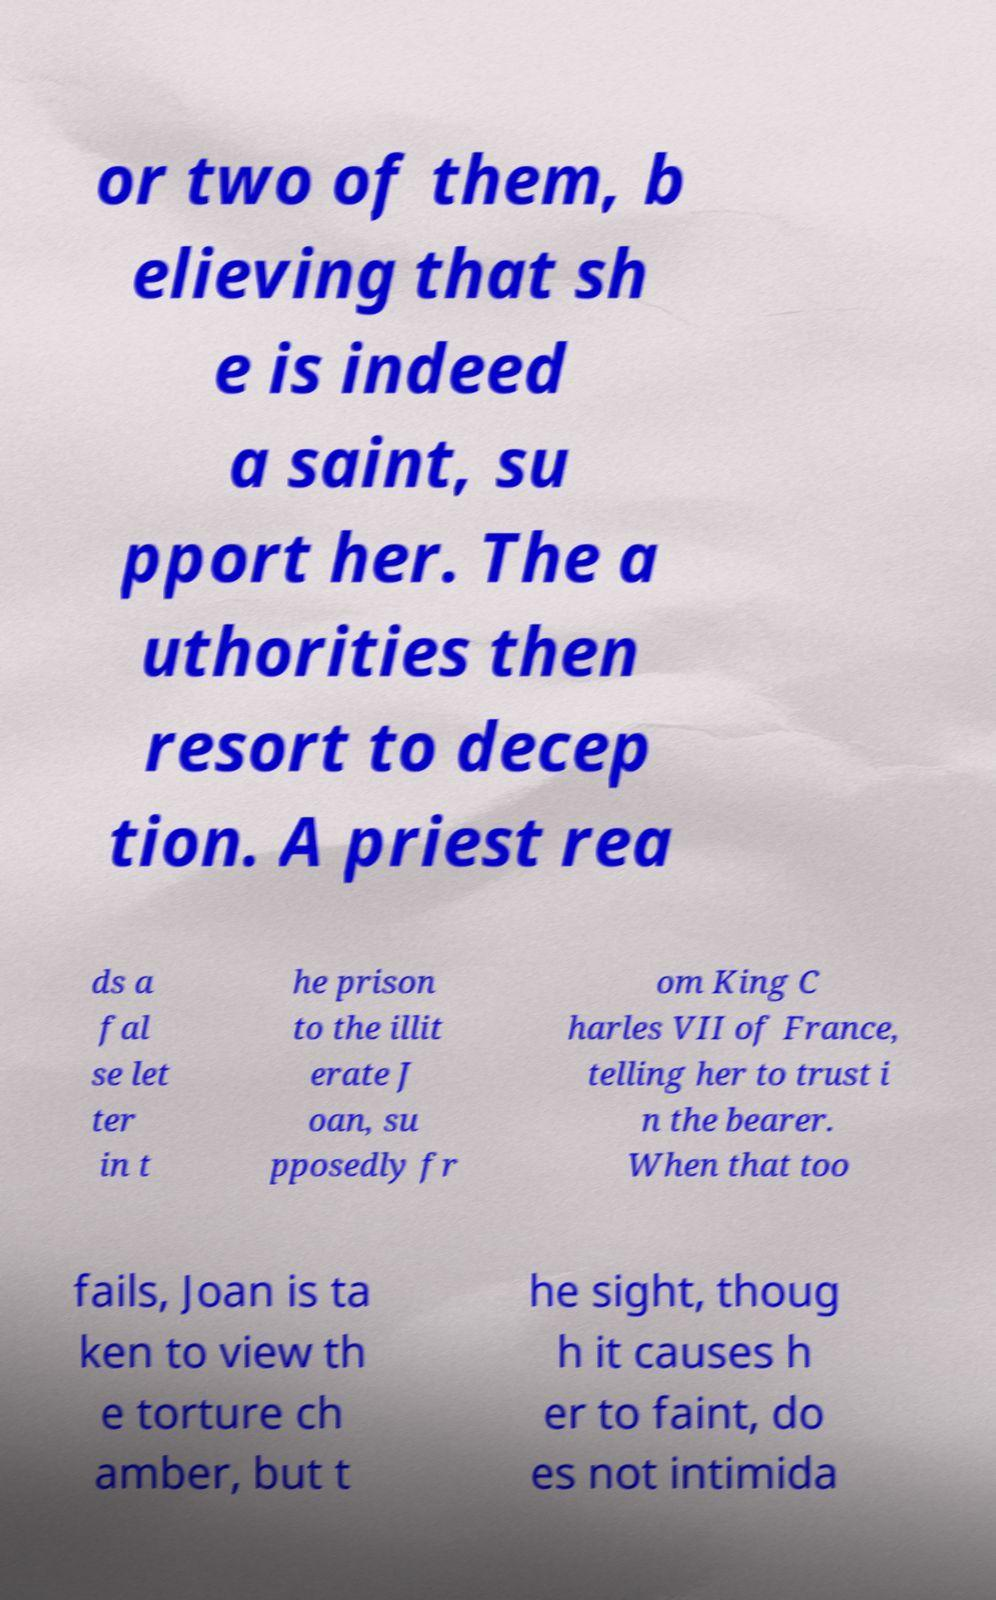Can you accurately transcribe the text from the provided image for me? or two of them, b elieving that sh e is indeed a saint, su pport her. The a uthorities then resort to decep tion. A priest rea ds a fal se let ter in t he prison to the illit erate J oan, su pposedly fr om King C harles VII of France, telling her to trust i n the bearer. When that too fails, Joan is ta ken to view th e torture ch amber, but t he sight, thoug h it causes h er to faint, do es not intimida 